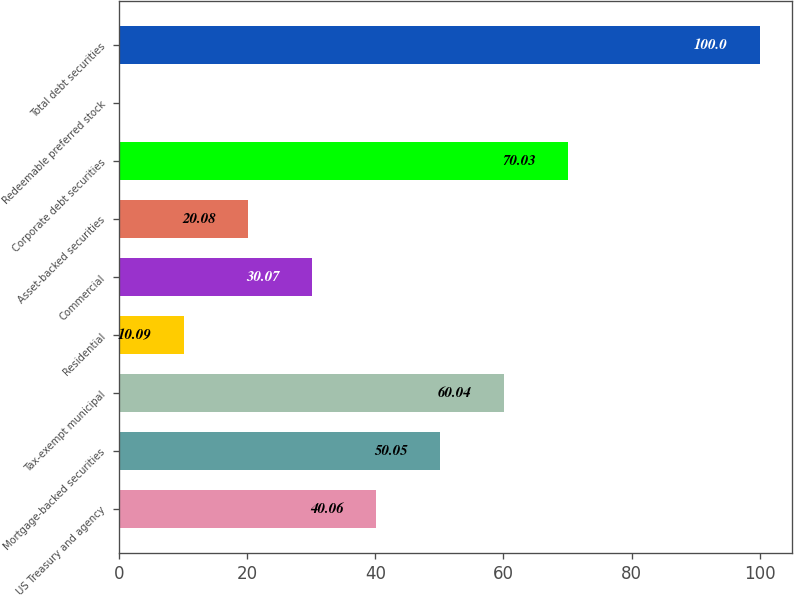Convert chart. <chart><loc_0><loc_0><loc_500><loc_500><bar_chart><fcel>US Treasury and agency<fcel>Mortgage-backed securities<fcel>Tax-exempt municipal<fcel>Residential<fcel>Commercial<fcel>Asset-backed securities<fcel>Corporate debt securities<fcel>Redeemable preferred stock<fcel>Total debt securities<nl><fcel>40.06<fcel>50.05<fcel>60.04<fcel>10.09<fcel>30.07<fcel>20.08<fcel>70.03<fcel>0.1<fcel>100<nl></chart> 